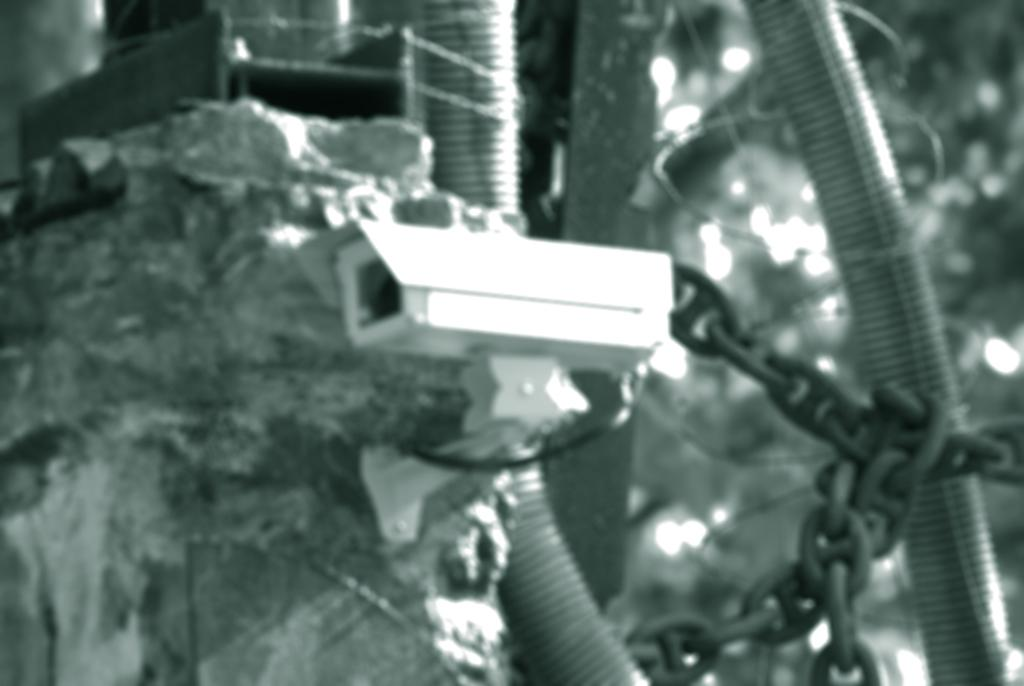What is the main object in the picture? There is a CC camera in the picture. Where is the CC camera located? The CC camera is attached to the wall. What else can be seen in the image besides the CC camera? Pipes are visible in the image. What type of flag is being waved at the party in the image? There is no flag or party present in the image; it only features a CC camera attached to the wall and visible pipes. 